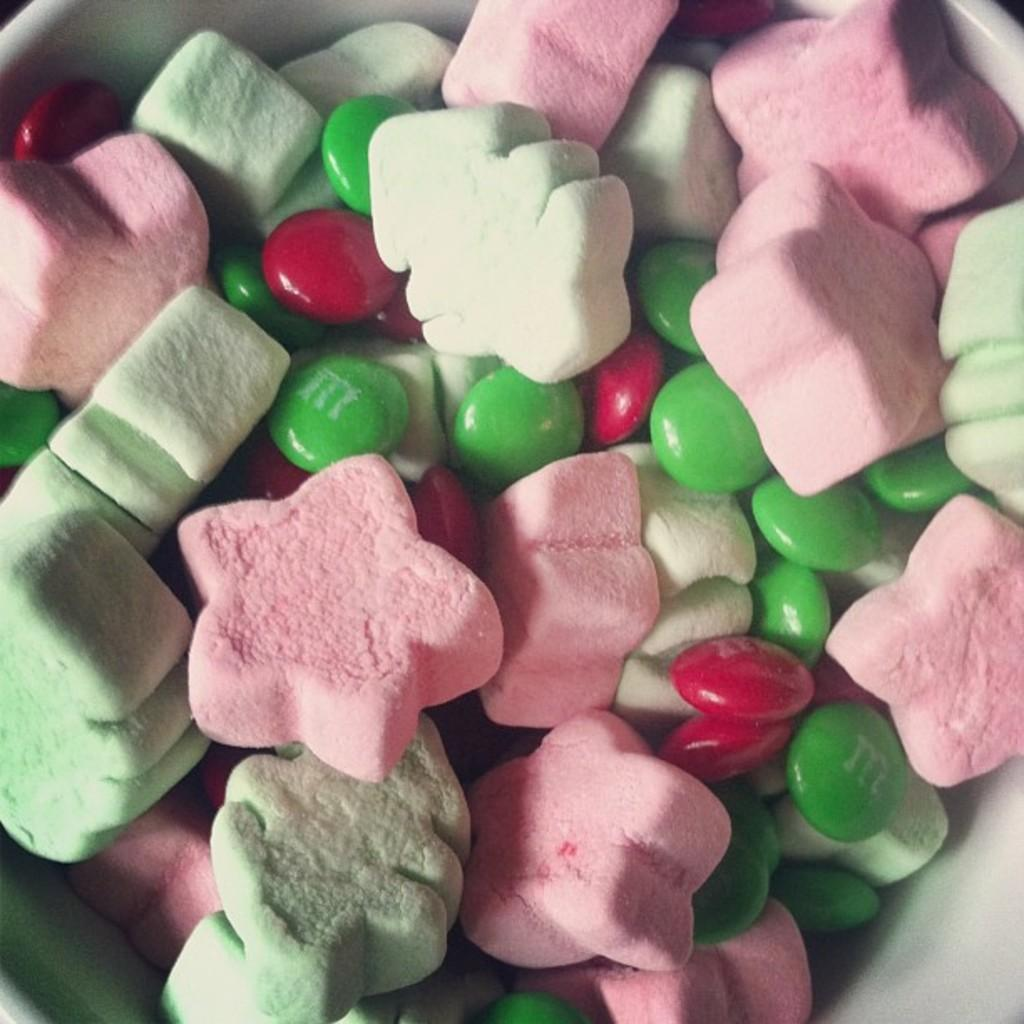What is the main object in the center of the image? There is a bowl in the middle of the image. What is inside the bowl? The bowl contains many candies and marshmallows. What type of flowers can be seen growing out of the boot in the image? There is no boot or flowers present in the image; it only features a bowl with candies and marshmallows. 